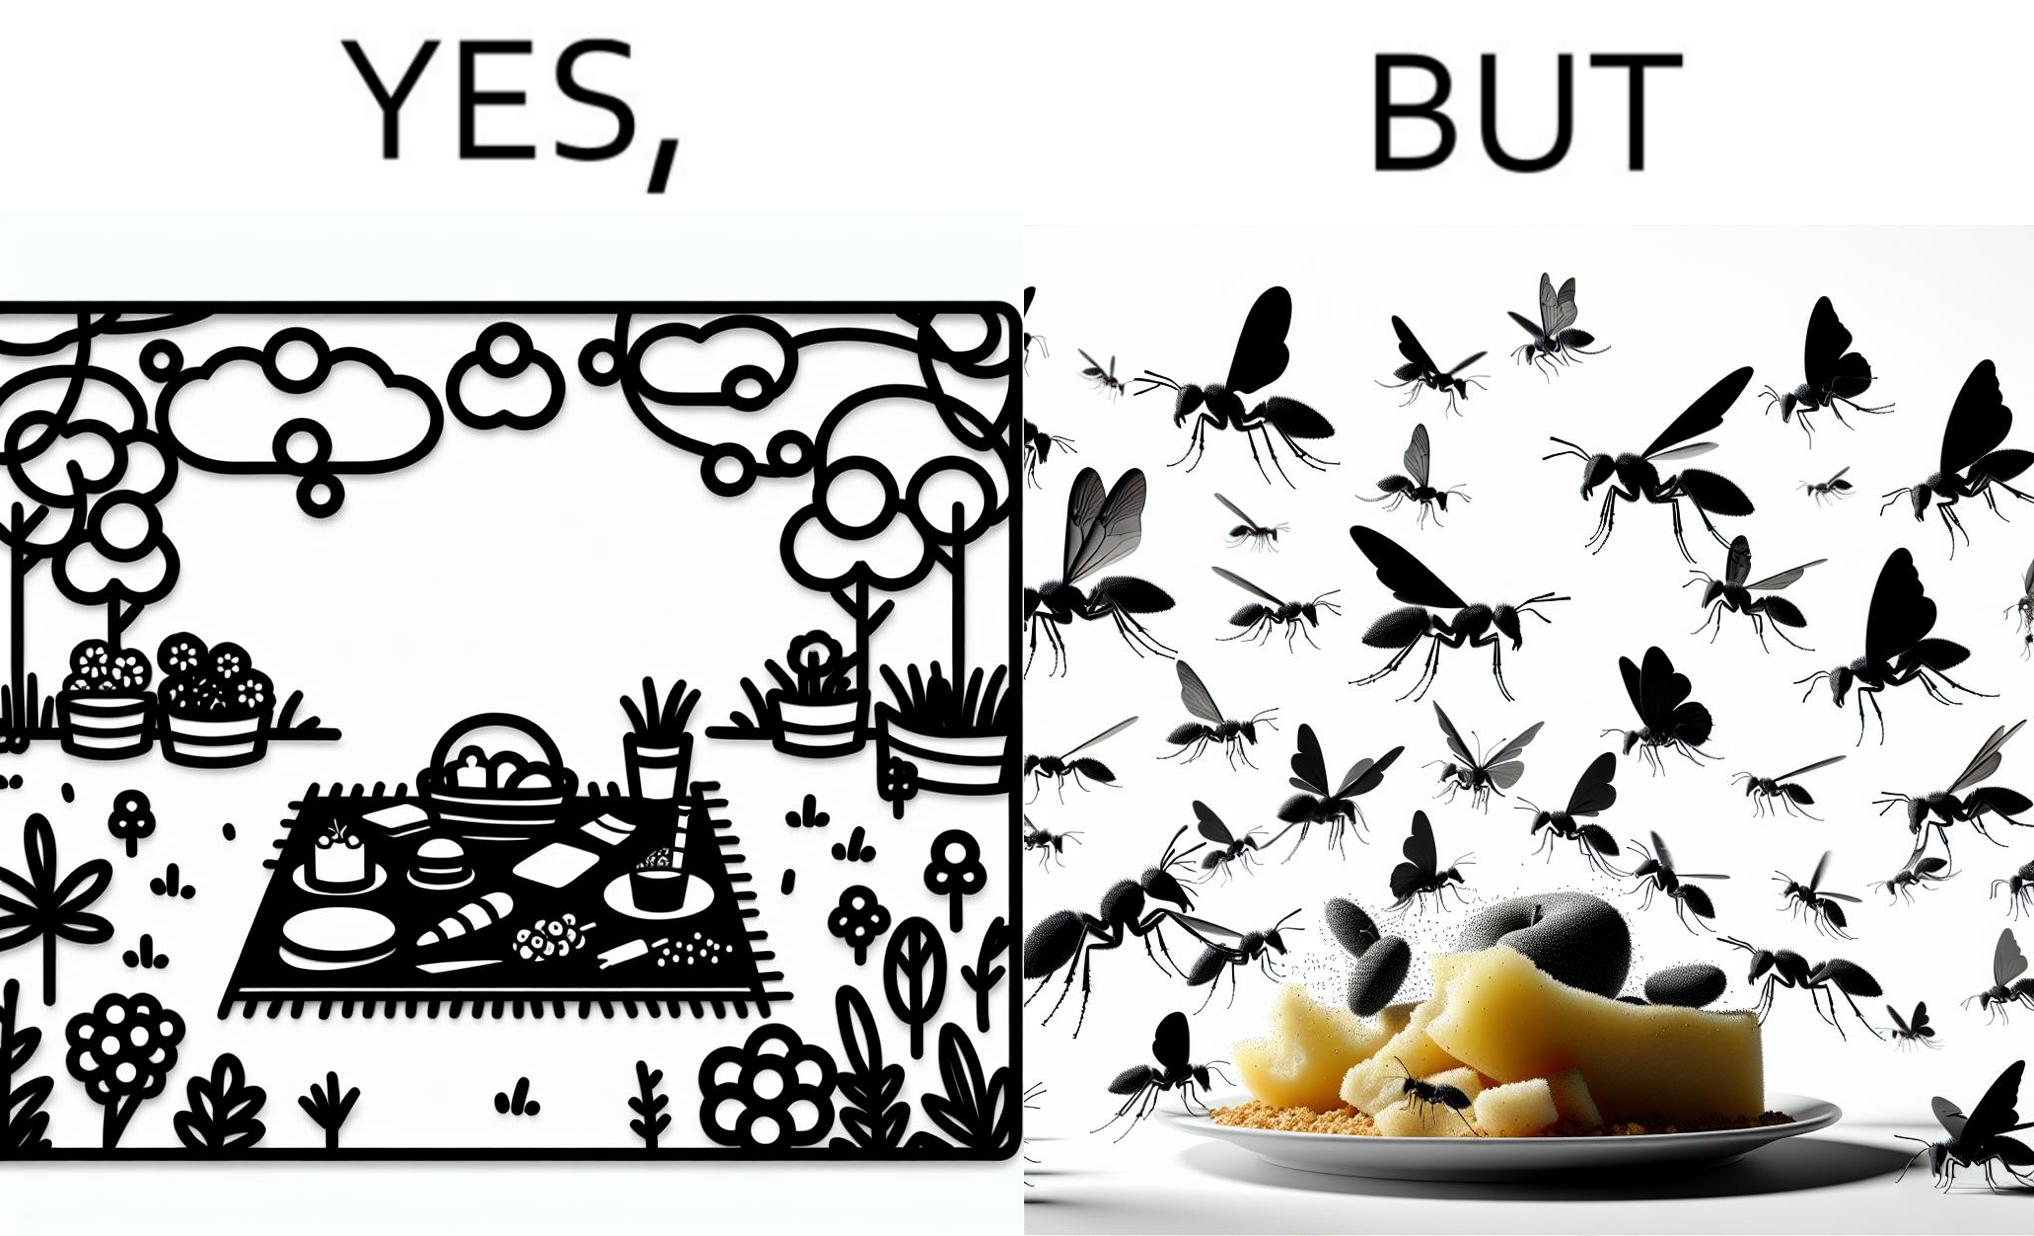Would you classify this image as satirical? Yes, this image is satirical. 